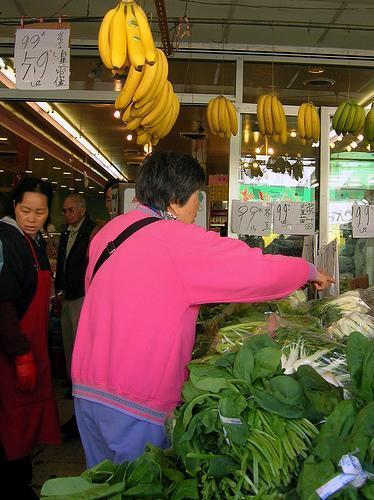How many people are at least partially shown?
Give a very brief answer. 4. 